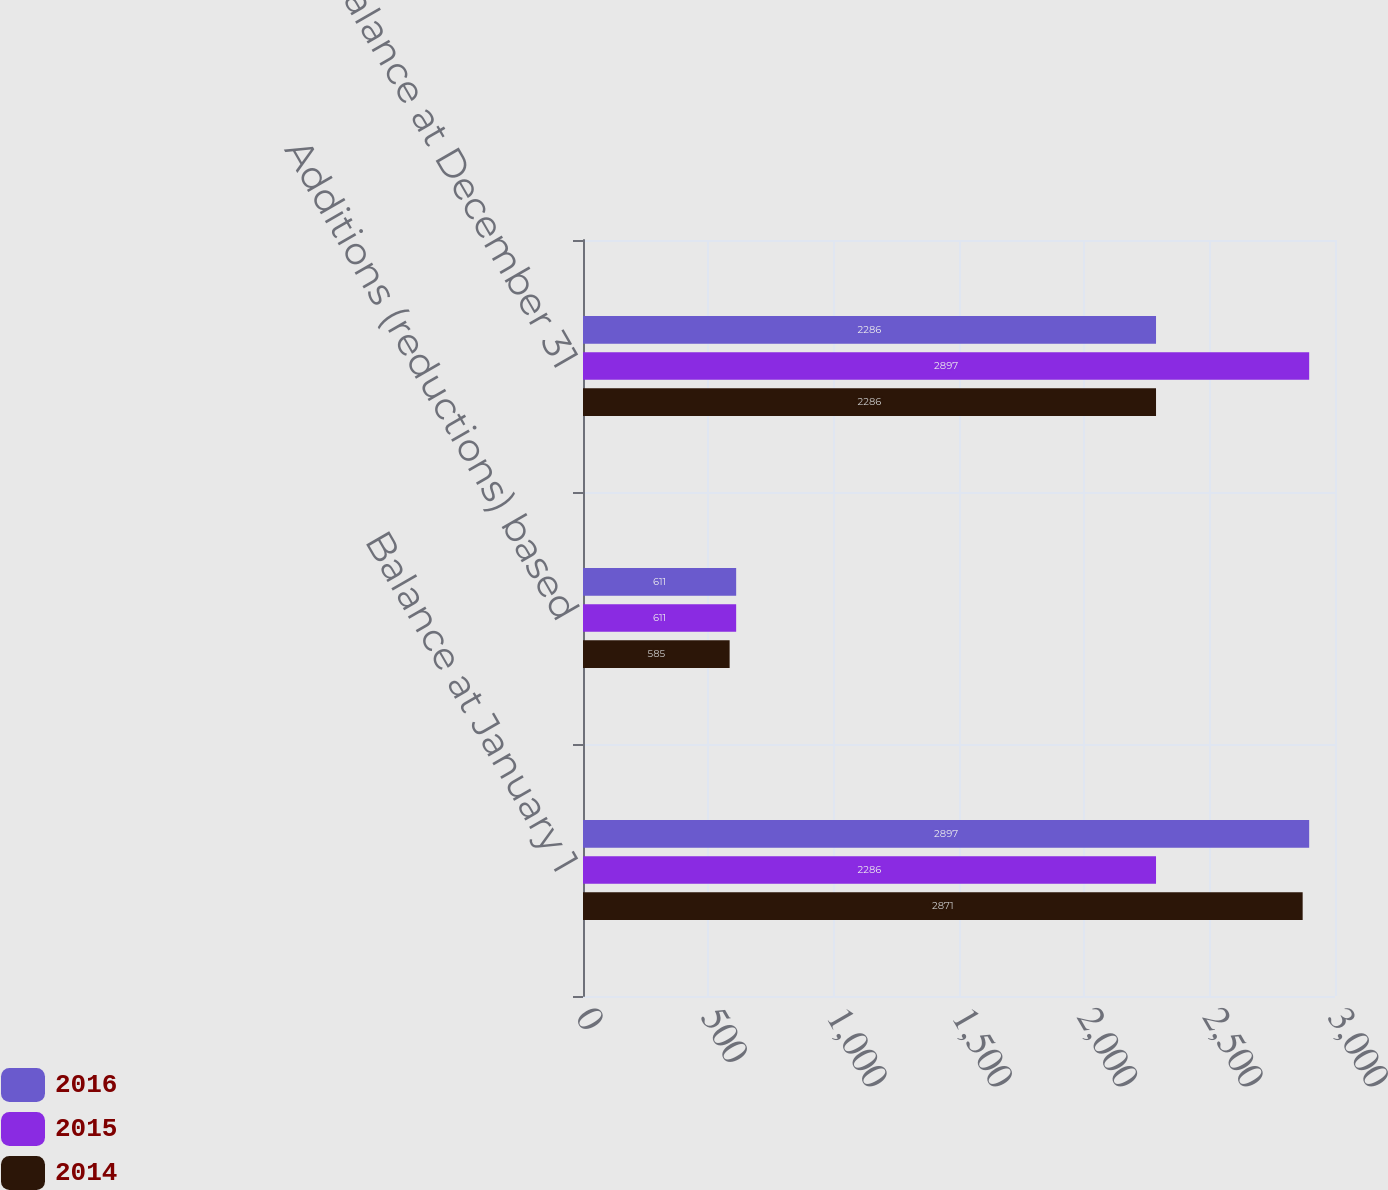Convert chart. <chart><loc_0><loc_0><loc_500><loc_500><stacked_bar_chart><ecel><fcel>Balance at January 1<fcel>Additions (reductions) based<fcel>Balance at December 31<nl><fcel>2016<fcel>2897<fcel>611<fcel>2286<nl><fcel>2015<fcel>2286<fcel>611<fcel>2897<nl><fcel>2014<fcel>2871<fcel>585<fcel>2286<nl></chart> 